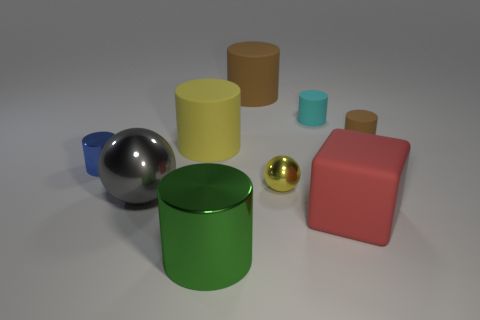What is the size of the cylinder that is the same color as the tiny shiny ball?
Ensure brevity in your answer.  Large. What shape is the big rubber thing that is left of the large matte object that is behind the big matte cylinder that is in front of the small cyan cylinder?
Your answer should be very brief. Cylinder. What number of green objects are either large cylinders or tiny spheres?
Your answer should be very brief. 1. How many matte objects are behind the cylinder that is left of the gray object?
Give a very brief answer. 4. Is there anything else that is the same color as the rubber block?
Provide a short and direct response. No. What shape is the large green object that is the same material as the blue thing?
Make the answer very short. Cylinder. Is the large sphere the same color as the large metal cylinder?
Your response must be concise. No. Are the brown cylinder that is behind the tiny cyan rubber thing and the brown cylinder that is on the right side of the yellow ball made of the same material?
Provide a short and direct response. Yes. How many things are either big yellow rubber cubes or small cyan objects behind the tiny yellow ball?
Your answer should be compact. 1. Is there any other thing that has the same material as the large red block?
Make the answer very short. Yes. 